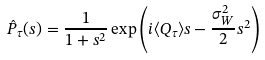Convert formula to latex. <formula><loc_0><loc_0><loc_500><loc_500>\hat { P } _ { \tau } ( s ) = \frac { 1 } { 1 + s ^ { 2 } } \exp \left ( i \langle Q _ { \tau } \rangle s - \frac { \sigma _ { W } ^ { 2 } } { 2 } s ^ { 2 } \right )</formula> 